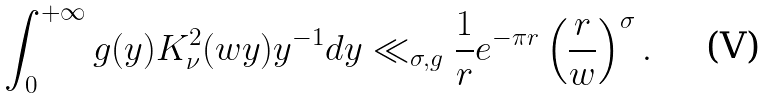Convert formula to latex. <formula><loc_0><loc_0><loc_500><loc_500>\int ^ { + \infty } _ { 0 } g ( y ) K ^ { 2 } _ { \nu } ( w y ) y ^ { - 1 } d y \ll _ { \sigma , g } \frac { 1 } { r } e ^ { - \pi r } \left ( \frac { r } { w } \right ) ^ { \sigma } .</formula> 